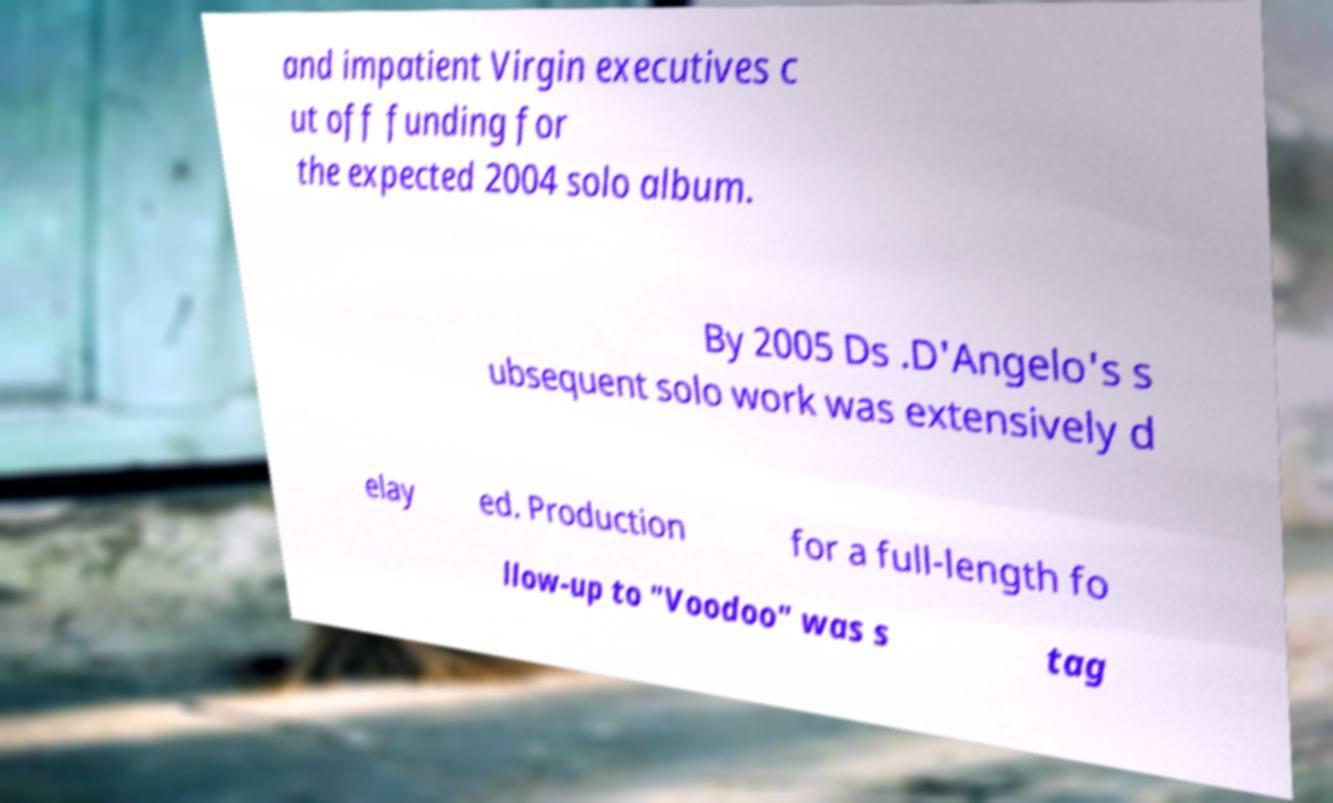Could you extract and type out the text from this image? and impatient Virgin executives c ut off funding for the expected 2004 solo album. By 2005 Ds .D'Angelo's s ubsequent solo work was extensively d elay ed. Production for a full-length fo llow-up to "Voodoo" was s tag 